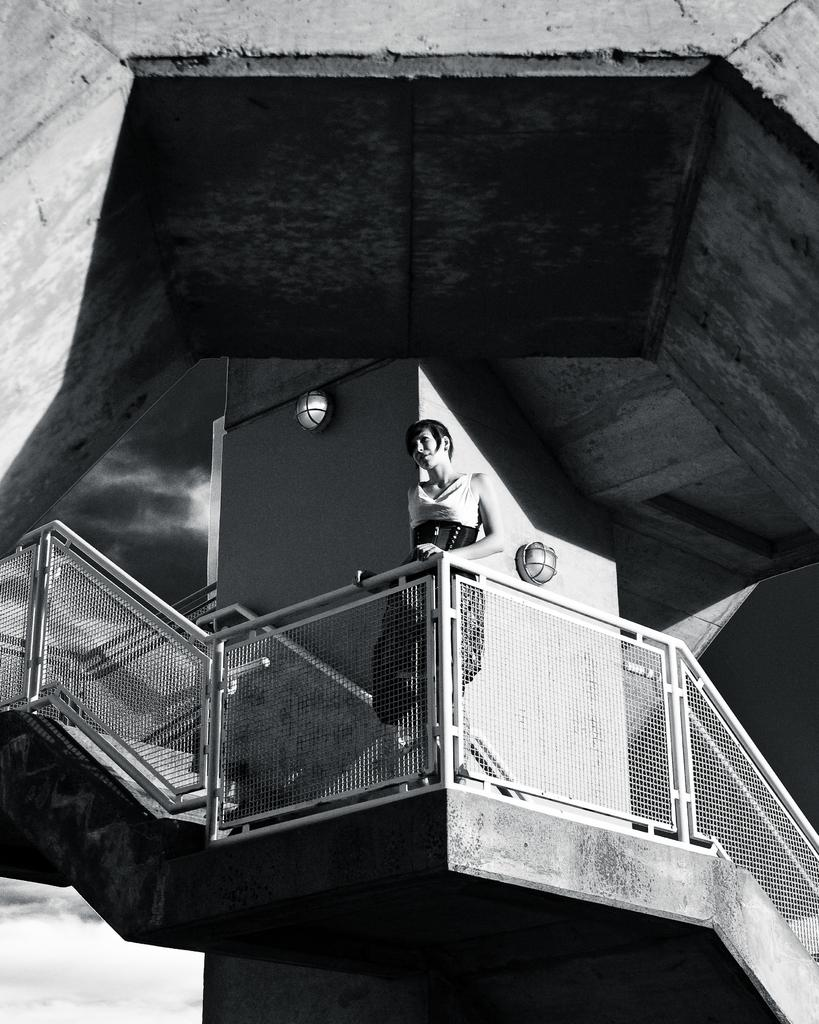What is the main subject of the image? There is a person standing in the image. What type of structure can be seen in the image? There is fencing and a pillar in the image. What is visible in the background of the image? The sky is visible in the image. How is the image presented in terms of color? The image is in black and white. Reasoning: Let' Let's think step by step in order to produce the conversation. We start by identifying the main subject of the image, which is the person standing. Then, we describe the structures present in the image, such as the fencing and pillar. Next, we mention the background of the image, which is the sky. Finally, we note the color scheme of the image, which is black and white. Absurd Question/Answer: What type of twist is being performed by the person in the image? There is no twist being performed by the person in the image; they are simply standing. How many quarters are visible in the image? There are no quarters present in the image. 